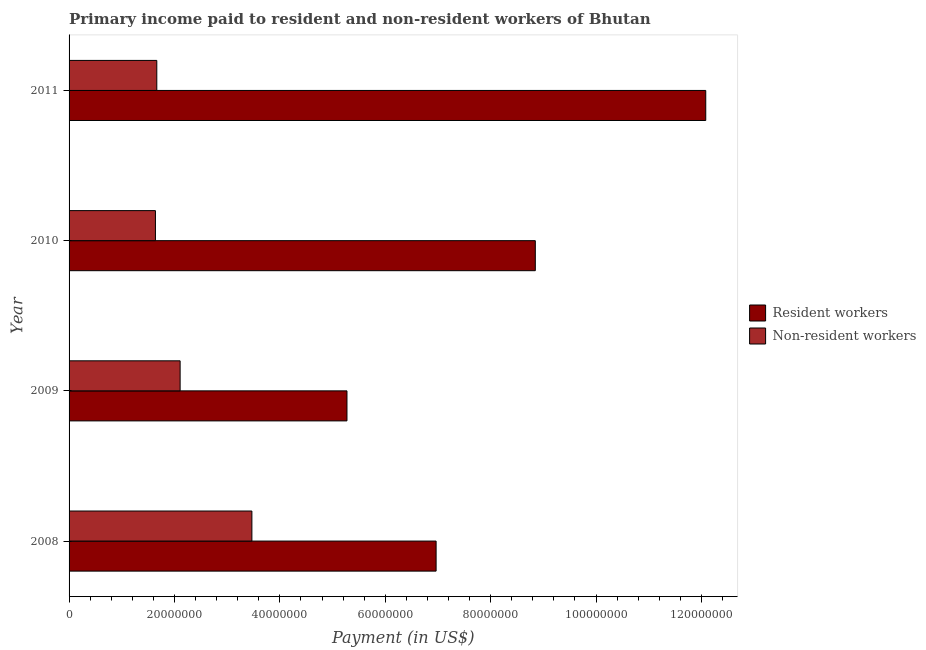How many different coloured bars are there?
Your answer should be very brief. 2. Are the number of bars per tick equal to the number of legend labels?
Provide a short and direct response. Yes. How many bars are there on the 4th tick from the bottom?
Offer a terse response. 2. What is the label of the 1st group of bars from the top?
Make the answer very short. 2011. What is the payment made to non-resident workers in 2010?
Your response must be concise. 1.64e+07. Across all years, what is the maximum payment made to resident workers?
Your answer should be very brief. 1.21e+08. Across all years, what is the minimum payment made to non-resident workers?
Provide a short and direct response. 1.64e+07. In which year was the payment made to non-resident workers maximum?
Your answer should be compact. 2008. In which year was the payment made to resident workers minimum?
Keep it short and to the point. 2009. What is the total payment made to non-resident workers in the graph?
Offer a terse response. 8.88e+07. What is the difference between the payment made to non-resident workers in 2009 and that in 2010?
Your answer should be compact. 4.68e+06. What is the difference between the payment made to non-resident workers in 2009 and the payment made to resident workers in 2011?
Provide a short and direct response. -9.98e+07. What is the average payment made to resident workers per year?
Offer a terse response. 8.29e+07. In the year 2009, what is the difference between the payment made to resident workers and payment made to non-resident workers?
Keep it short and to the point. 3.17e+07. In how many years, is the payment made to non-resident workers greater than 28000000 US$?
Provide a succinct answer. 1. What is the ratio of the payment made to resident workers in 2008 to that in 2011?
Make the answer very short. 0.58. What is the difference between the highest and the second highest payment made to resident workers?
Your response must be concise. 3.23e+07. What is the difference between the highest and the lowest payment made to resident workers?
Make the answer very short. 6.81e+07. What does the 1st bar from the top in 2009 represents?
Your answer should be compact. Non-resident workers. What does the 1st bar from the bottom in 2009 represents?
Offer a very short reply. Resident workers. How many years are there in the graph?
Ensure brevity in your answer.  4. What is the difference between two consecutive major ticks on the X-axis?
Make the answer very short. 2.00e+07. Are the values on the major ticks of X-axis written in scientific E-notation?
Your answer should be very brief. No. How many legend labels are there?
Your answer should be very brief. 2. What is the title of the graph?
Provide a succinct answer. Primary income paid to resident and non-resident workers of Bhutan. Does "Researchers" appear as one of the legend labels in the graph?
Offer a terse response. No. What is the label or title of the X-axis?
Ensure brevity in your answer.  Payment (in US$). What is the label or title of the Y-axis?
Your response must be concise. Year. What is the Payment (in US$) of Resident workers in 2008?
Your answer should be compact. 6.97e+07. What is the Payment (in US$) in Non-resident workers in 2008?
Your answer should be compact. 3.47e+07. What is the Payment (in US$) of Resident workers in 2009?
Provide a succinct answer. 5.27e+07. What is the Payment (in US$) of Non-resident workers in 2009?
Make the answer very short. 2.11e+07. What is the Payment (in US$) in Resident workers in 2010?
Give a very brief answer. 8.85e+07. What is the Payment (in US$) of Non-resident workers in 2010?
Your response must be concise. 1.64e+07. What is the Payment (in US$) of Resident workers in 2011?
Your answer should be very brief. 1.21e+08. What is the Payment (in US$) in Non-resident workers in 2011?
Keep it short and to the point. 1.66e+07. Across all years, what is the maximum Payment (in US$) in Resident workers?
Your answer should be compact. 1.21e+08. Across all years, what is the maximum Payment (in US$) of Non-resident workers?
Your answer should be compact. 3.47e+07. Across all years, what is the minimum Payment (in US$) in Resident workers?
Your answer should be compact. 5.27e+07. Across all years, what is the minimum Payment (in US$) in Non-resident workers?
Offer a very short reply. 1.64e+07. What is the total Payment (in US$) of Resident workers in the graph?
Give a very brief answer. 3.32e+08. What is the total Payment (in US$) of Non-resident workers in the graph?
Give a very brief answer. 8.88e+07. What is the difference between the Payment (in US$) in Resident workers in 2008 and that in 2009?
Give a very brief answer. 1.69e+07. What is the difference between the Payment (in US$) of Non-resident workers in 2008 and that in 2009?
Provide a succinct answer. 1.36e+07. What is the difference between the Payment (in US$) in Resident workers in 2008 and that in 2010?
Provide a succinct answer. -1.88e+07. What is the difference between the Payment (in US$) of Non-resident workers in 2008 and that in 2010?
Your response must be concise. 1.83e+07. What is the difference between the Payment (in US$) of Resident workers in 2008 and that in 2011?
Your answer should be very brief. -5.12e+07. What is the difference between the Payment (in US$) of Non-resident workers in 2008 and that in 2011?
Your answer should be very brief. 1.80e+07. What is the difference between the Payment (in US$) of Resident workers in 2009 and that in 2010?
Your answer should be compact. -3.57e+07. What is the difference between the Payment (in US$) in Non-resident workers in 2009 and that in 2010?
Keep it short and to the point. 4.68e+06. What is the difference between the Payment (in US$) of Resident workers in 2009 and that in 2011?
Your answer should be very brief. -6.81e+07. What is the difference between the Payment (in US$) in Non-resident workers in 2009 and that in 2011?
Give a very brief answer. 4.43e+06. What is the difference between the Payment (in US$) in Resident workers in 2010 and that in 2011?
Your answer should be compact. -3.23e+07. What is the difference between the Payment (in US$) of Non-resident workers in 2010 and that in 2011?
Offer a terse response. -2.57e+05. What is the difference between the Payment (in US$) of Resident workers in 2008 and the Payment (in US$) of Non-resident workers in 2009?
Offer a very short reply. 4.86e+07. What is the difference between the Payment (in US$) of Resident workers in 2008 and the Payment (in US$) of Non-resident workers in 2010?
Make the answer very short. 5.33e+07. What is the difference between the Payment (in US$) of Resident workers in 2008 and the Payment (in US$) of Non-resident workers in 2011?
Offer a very short reply. 5.30e+07. What is the difference between the Payment (in US$) in Resident workers in 2009 and the Payment (in US$) in Non-resident workers in 2010?
Make the answer very short. 3.63e+07. What is the difference between the Payment (in US$) in Resident workers in 2009 and the Payment (in US$) in Non-resident workers in 2011?
Make the answer very short. 3.61e+07. What is the difference between the Payment (in US$) in Resident workers in 2010 and the Payment (in US$) in Non-resident workers in 2011?
Provide a succinct answer. 7.18e+07. What is the average Payment (in US$) of Resident workers per year?
Provide a short and direct response. 8.29e+07. What is the average Payment (in US$) of Non-resident workers per year?
Give a very brief answer. 2.22e+07. In the year 2008, what is the difference between the Payment (in US$) in Resident workers and Payment (in US$) in Non-resident workers?
Provide a succinct answer. 3.50e+07. In the year 2009, what is the difference between the Payment (in US$) in Resident workers and Payment (in US$) in Non-resident workers?
Give a very brief answer. 3.17e+07. In the year 2010, what is the difference between the Payment (in US$) of Resident workers and Payment (in US$) of Non-resident workers?
Make the answer very short. 7.21e+07. In the year 2011, what is the difference between the Payment (in US$) of Resident workers and Payment (in US$) of Non-resident workers?
Provide a short and direct response. 1.04e+08. What is the ratio of the Payment (in US$) in Resident workers in 2008 to that in 2009?
Make the answer very short. 1.32. What is the ratio of the Payment (in US$) of Non-resident workers in 2008 to that in 2009?
Provide a short and direct response. 1.65. What is the ratio of the Payment (in US$) in Resident workers in 2008 to that in 2010?
Provide a succinct answer. 0.79. What is the ratio of the Payment (in US$) in Non-resident workers in 2008 to that in 2010?
Ensure brevity in your answer.  2.12. What is the ratio of the Payment (in US$) in Resident workers in 2008 to that in 2011?
Ensure brevity in your answer.  0.58. What is the ratio of the Payment (in US$) in Non-resident workers in 2008 to that in 2011?
Offer a terse response. 2.08. What is the ratio of the Payment (in US$) in Resident workers in 2009 to that in 2010?
Provide a succinct answer. 0.6. What is the ratio of the Payment (in US$) in Resident workers in 2009 to that in 2011?
Give a very brief answer. 0.44. What is the ratio of the Payment (in US$) in Non-resident workers in 2009 to that in 2011?
Your response must be concise. 1.27. What is the ratio of the Payment (in US$) of Resident workers in 2010 to that in 2011?
Offer a very short reply. 0.73. What is the ratio of the Payment (in US$) of Non-resident workers in 2010 to that in 2011?
Make the answer very short. 0.98. What is the difference between the highest and the second highest Payment (in US$) in Resident workers?
Provide a succinct answer. 3.23e+07. What is the difference between the highest and the second highest Payment (in US$) of Non-resident workers?
Your response must be concise. 1.36e+07. What is the difference between the highest and the lowest Payment (in US$) in Resident workers?
Your answer should be compact. 6.81e+07. What is the difference between the highest and the lowest Payment (in US$) of Non-resident workers?
Offer a very short reply. 1.83e+07. 